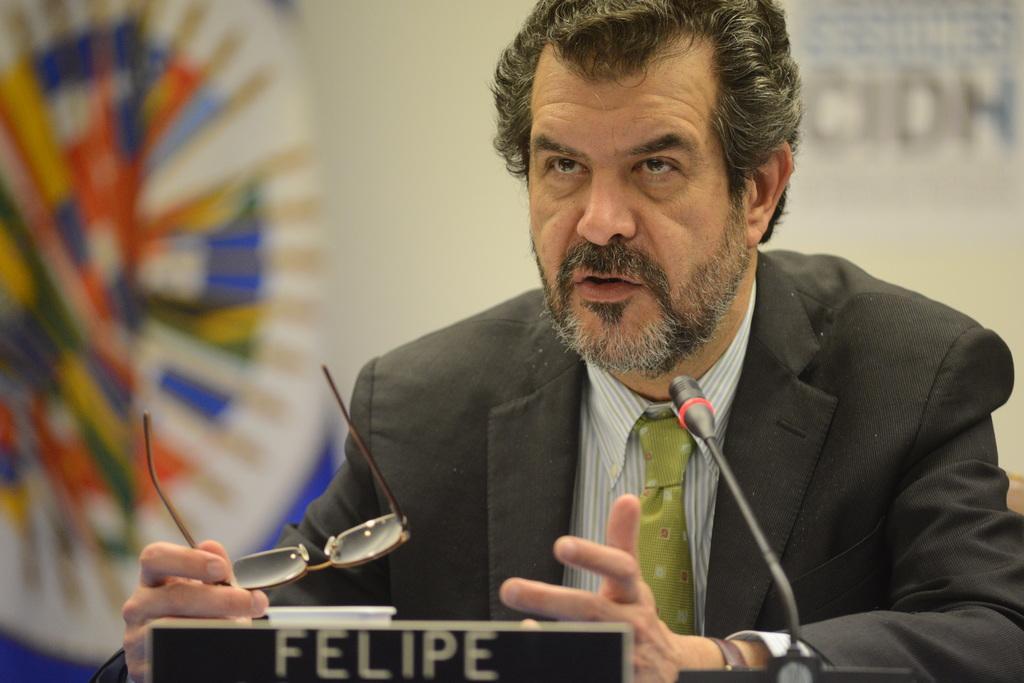In one or two sentences, can you explain what this image depicts? In this image we can see a person talking and holding spectacles. In front of the person we can see a microphone and board with text and blur background. 